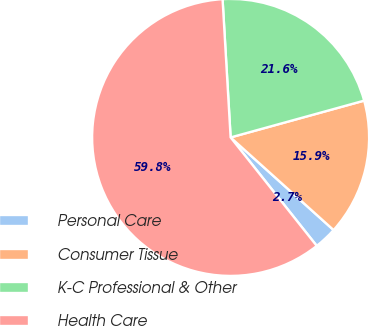<chart> <loc_0><loc_0><loc_500><loc_500><pie_chart><fcel>Personal Care<fcel>Consumer Tissue<fcel>K-C Professional & Other<fcel>Health Care<nl><fcel>2.66%<fcel>15.94%<fcel>21.65%<fcel>59.76%<nl></chart> 